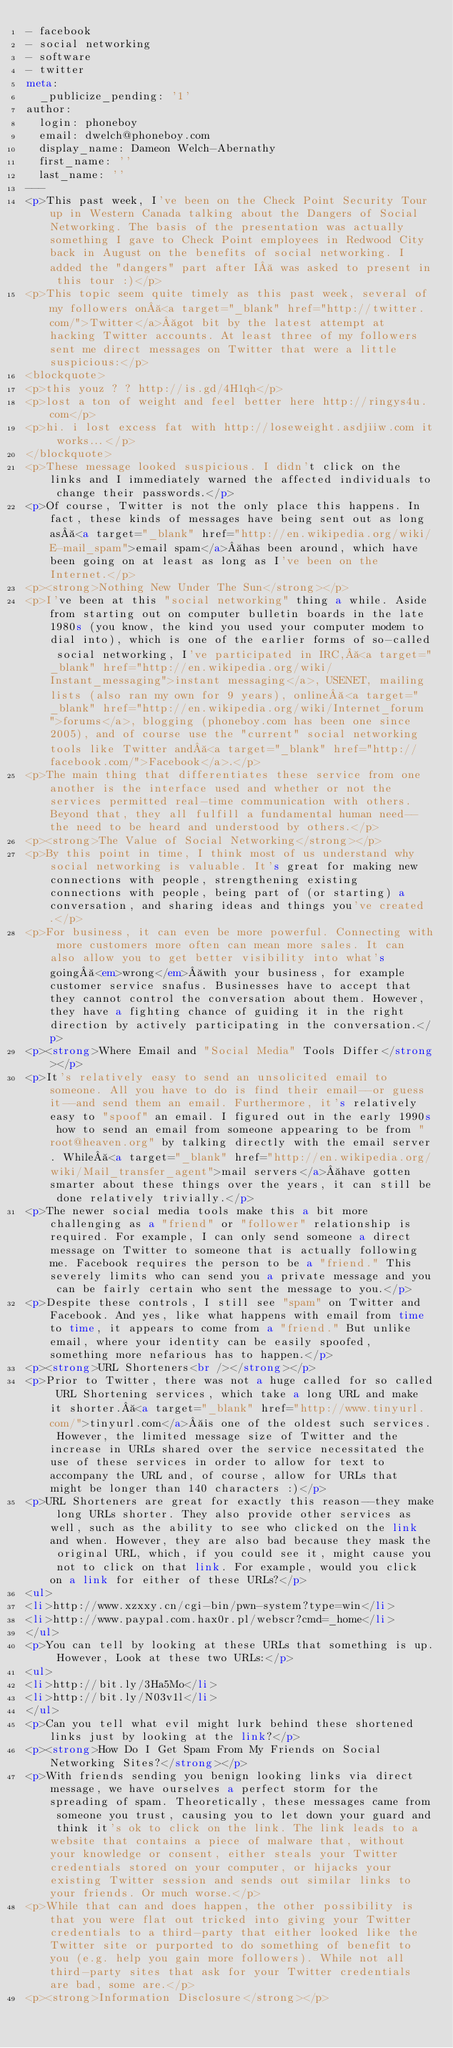Convert code to text. <code><loc_0><loc_0><loc_500><loc_500><_HTML_>- facebook
- social networking
- software
- twitter
meta:
  _publicize_pending: '1'
author:
  login: phoneboy
  email: dwelch@phoneboy.com
  display_name: Dameon Welch-Abernathy
  first_name: ''
  last_name: ''
---
<p>This past week, I've been on the Check Point Security Tour up in Western Canada talking about the Dangers of Social Networking. The basis of the presentation was actually something I gave to Check Point employees in Redwood City back in August on the benefits of social networking. I added the "dangers" part after I  was asked to present in this tour :)</p>
<p>This topic seem quite timely as this past week, several of my followers on <a target="_blank" href="http://twitter.com/">Twitter</a> got bit by the latest attempt at hacking Twitter accounts. At least three of my followers sent me direct messages on Twitter that were a little suspicious:</p>
<blockquote>
<p>this youz ? ? http://is.gd/4H1qh</p>
<p>lost a ton of weight and feel better here http://ringys4u.com</p>
<p>hi. i lost excess fat with http://loseweight.asdjiiw.com it works...</p>
</blockquote>
<p>These message looked suspicious. I didn't click on the links and I immediately warned the affected individuals to change their passwords.</p>
<p>Of course, Twitter is not the only place this happens. In fact, these kinds of messages have being sent out as long as <a target="_blank" href="http://en.wikipedia.org/wiki/E-mail_spam">email spam</a> has been around, which have been going on at least as long as I've been on the Internet.</p>
<p><strong>Nothing New Under The Sun</strong></p>
<p>I've been at this "social networking" thing a while. Aside from starting out on computer bulletin boards in the late 1980s (you know, the kind you used your computer modem to dial into), which is one of the earlier forms of so-called social networking, I've participated in IRC, <a target="_blank" href="http://en.wikipedia.org/wiki/Instant_messaging">instant messaging</a>, USENET, mailing lists (also ran my own for 9 years), online <a target="_blank" href="http://en.wikipedia.org/wiki/Internet_forum">forums</a>, blogging (phoneboy.com has been one since 2005), and of course use the "current" social networking tools like Twitter and <a target="_blank" href="http://facebook.com/">Facebook</a>.</p>
<p>The main thing that differentiates these service from one another is the interface used and whether or not the services permitted real-time communication with others. Beyond that, they all fulfill a fundamental human need--the need to be heard and understood by others.</p>
<p><strong>The Value of Social Networking</strong></p>
<p>By this point in time, I think most of us understand why social networking is valuable. It's great for making new connections with people, strengthening existing connections with people, being part of (or starting) a conversation, and sharing ideas and things you've created.</p>
<p>For business, it can even be more powerful. Connecting with more customers more often can mean more sales. It can also allow you to get better visibility into what's going <em>wrong</em> with your business, for example customer service snafus. Businesses have to accept that they cannot control the conversation about them. However, they have a fighting chance of guiding it in the right direction by actively participating in the conversation.</p>
<p><strong>Where Email and "Social Media" Tools Differ</strong></p>
<p>It's relatively easy to send an unsolicited email to someone. All you have to do is find their email--or guess it--and send them an email. Furthermore, it's relatively easy to "spoof" an email. I figured out in the early 1990s how to send an email from someone appearing to be from "root@heaven.org" by talking directly with the email server. While <a target="_blank" href="http://en.wikipedia.org/wiki/Mail_transfer_agent">mail servers</a> have gotten smarter about these things over the years, it can still be done relatively trivially.</p>
<p>The newer social media tools make this a bit more challenging as a "friend" or "follower" relationship is required. For example, I can only send someone a direct message on Twitter to someone that is actually following me. Facebook requires the person to be a "friend." This severely limits who can send you a private message and you can be fairly certain who sent the message to you.</p>
<p>Despite these controls, I still see "spam" on Twitter and Facebook. And yes, like what happens with email from time to time, it appears to come from a "friend." But unlike email, where your identity can be easily spoofed, something more nefarious has to happen.</p>
<p><strong>URL Shorteners<br /></strong></p>
<p>Prior to Twitter, there was not a huge called for so called URL Shortening services, which take a long URL and make it shorter. <a target="_blank" href="http://www.tinyurl.com/">tinyurl.com</a> is one of the oldest such services. However, the limited message size of Twitter and the increase in URLs shared over the service necessitated the use of these services in order to allow for text to accompany the URL and, of course, allow for URLs that might be longer than 140 characters :)</p>
<p>URL Shorteners are great for exactly this reason--they make long URLs shorter. They also provide other services as well, such as the ability to see who clicked on the link and when. However, they are also bad because they mask the original URL, which, if you could see it, might cause you not to click on that link. For example, would you click on a link for either of these URLs?</p>
<ul>
<li>http://www.xzxxy.cn/cgi-bin/pwn-system?type=win</li>
<li>http://www.paypal.com.hax0r.pl/webscr?cmd=_home</li>
</ul>
<p>You can tell by looking at these URLs that something is up. However, Look at these two URLs:</p>
<ul>
<li>http://bit.ly/3Ha5Mo</li>
<li>http://bit.ly/N03v1l</li>
</ul>
<p>Can you tell what evil might lurk behind these shortened links just by looking at the link?</p>
<p><strong>How Do I Get Spam From My Friends on Social Networking Sites?</strong></p>
<p>With friends sending you benign looking links via direct message, we have ourselves a perfect storm for the spreading of spam. Theoretically, these messages came from someone you trust, causing you to let down your guard and think it's ok to click on the link. The link leads to a website that contains a piece of malware that, without your knowledge or consent, either steals your Twitter credentials stored on your computer, or hijacks your existing Twitter session and sends out similar links to your friends. Or much worse.</p>
<p>While that can and does happen, the other possibility is that you were flat out tricked into giving your Twitter credentials to a third-party that either looked like the Twitter site or purported to do something of benefit to you (e.g. help you gain more followers). While not all third-party sites that ask for your Twitter credentials are bad, some are.</p>
<p><strong>Information Disclosure</strong></p></code> 